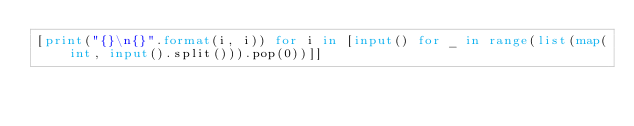<code> <loc_0><loc_0><loc_500><loc_500><_Python_>[print("{}\n{}".format(i, i)) for i in [input() for _ in range(list(map(int, input().split())).pop(0))]]</code> 